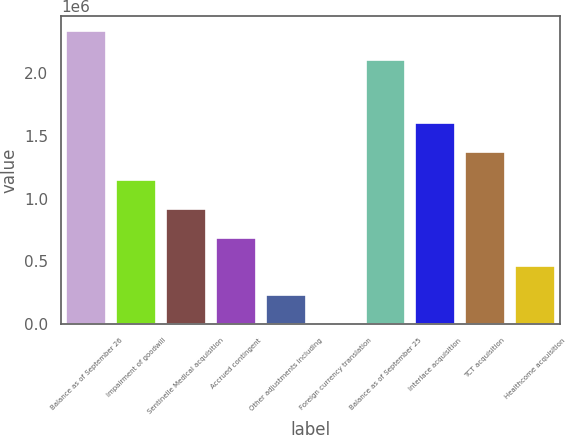Convert chart. <chart><loc_0><loc_0><loc_500><loc_500><bar_chart><fcel>Balance as of September 26<fcel>Impairment of goodwill<fcel>Sentinelle Medical acquisition<fcel>Accrued contingent<fcel>Other adjustments including<fcel>Foreign currency translation<fcel>Balance as of September 25<fcel>Interlace acquisition<fcel>TCT acquisition<fcel>Healthcome acquisition<nl><fcel>2.33779e+06<fcel>1.14563e+06<fcel>916695<fcel>687756<fcel>229877<fcel>938<fcel>2.10885e+06<fcel>1.60351e+06<fcel>1.37457e+06<fcel>458816<nl></chart> 